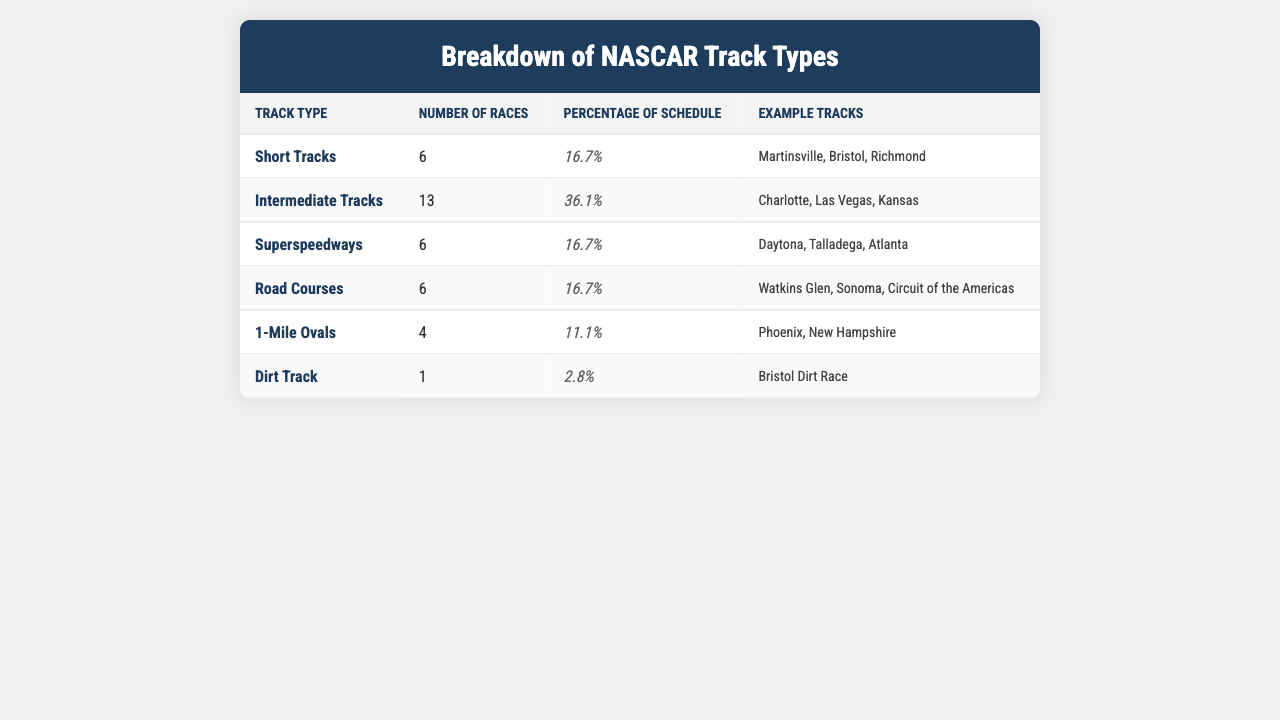What is the total number of races scheduled for the current Cup Series? To find the total, we sum the number of races across all track types: 6 + 13 + 6 + 6 + 4 + 1 = 36.
Answer: 36 Which track type has the highest percentage in the schedule? The highest percentage is for Intermediate Tracks at 36.1%.
Answer: Intermediate Tracks Is there a dirt track in the current Cup Series schedule? Yes, there is one dirt track scheduled, which is the Bristol Dirt Race.
Answer: Yes What is the combined percentage of Short Tracks and Superspeedways? We add the percentages: 16.7% (Short Tracks) + 16.7% (Superspeedways) = 33.4%.
Answer: 33.4% How many more Intermediate Tracks are there compared to 1-Mile Ovals? To find this, subtract the number of 1-Mile Ovals from the number of Intermediate Tracks: 13 - 4 = 9.
Answer: 9 What percentage of the schedule consists of Road Courses and Dirt Tracks combined? The combined percentage is: 16.7% (Road Courses) + 2.8% (Dirt Track) = 19.5%.
Answer: 19.5% Which track type has the least number of races, and what is that number? The least number of races is 1, which is for the Dirt Track.
Answer: 1 If we consider the percentages, which two track types together make up less than 35%? The only track types together that make up less than 35% are 1-Mile Ovals (11.1%) and Dirt Track (2.8%), adding up to 13.9%.
Answer: 1-Mile Ovals and Dirt Track What is the average number of races per track type? To find the average, divide the total number of races (36) by the number of track types (6): 36/6 = 6.
Answer: 6 Are there any track types with an equal number of races? Yes, Short Tracks, Superspeedways, and Road Courses each have 6 races scheduled.
Answer: Yes 